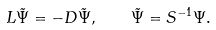Convert formula to latex. <formula><loc_0><loc_0><loc_500><loc_500>L \tilde { \Psi } = - D \tilde { \Psi } , \quad \tilde { \Psi } = S ^ { - 1 } \Psi .</formula> 